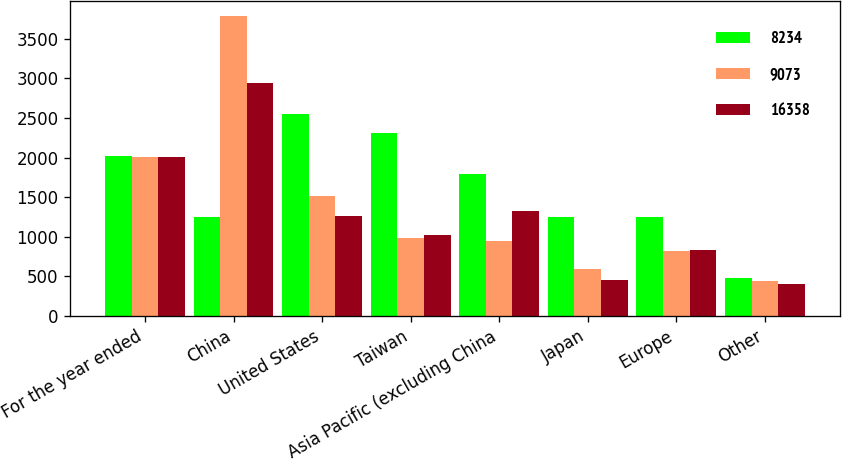Convert chart. <chart><loc_0><loc_0><loc_500><loc_500><stacked_bar_chart><ecel><fcel>For the year ended<fcel>China<fcel>United States<fcel>Taiwan<fcel>Asia Pacific (excluding China<fcel>Japan<fcel>Europe<fcel>Other<nl><fcel>8234<fcel>2014<fcel>1253<fcel>2551<fcel>2313<fcel>1791<fcel>1253<fcel>1252<fcel>483<nl><fcel>9073<fcel>2013<fcel>3783<fcel>1512<fcel>980<fcel>946<fcel>589<fcel>820<fcel>443<nl><fcel>16358<fcel>2012<fcel>2936<fcel>1262<fcel>1022<fcel>1327<fcel>460<fcel>827<fcel>400<nl></chart> 